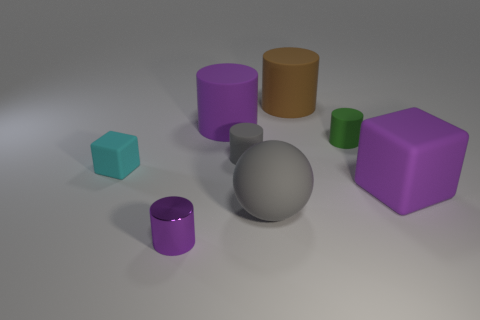Subtract all brown rubber cylinders. How many cylinders are left? 4 Subtract 1 cylinders. How many cylinders are left? 4 Subtract all brown cylinders. How many cylinders are left? 4 Subtract all cyan cylinders. Subtract all brown spheres. How many cylinders are left? 5 Add 1 big gray rubber objects. How many objects exist? 9 Subtract all spheres. How many objects are left? 7 Add 1 large yellow metal cubes. How many large yellow metal cubes exist? 1 Subtract 0 red cylinders. How many objects are left? 8 Subtract all small cyan metal cylinders. Subtract all large balls. How many objects are left? 7 Add 4 big purple cylinders. How many big purple cylinders are left? 5 